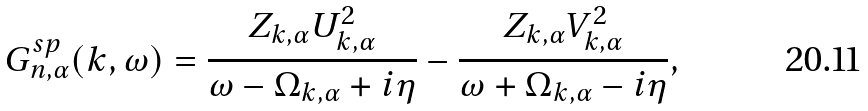<formula> <loc_0><loc_0><loc_500><loc_500>G _ { n , \alpha } ^ { s p } ( k , \omega ) = \frac { Z _ { k , \alpha } U _ { k , \alpha } ^ { 2 } } { \omega - \Omega _ { k , \alpha } + i \eta } - \frac { Z _ { k , \alpha } V _ { k , \alpha } ^ { 2 } } { \omega + \Omega _ { k , \alpha } - i \eta } ,</formula> 